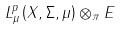Convert formula to latex. <formula><loc_0><loc_0><loc_500><loc_500>L _ { \mu } ^ { p } \left ( X , \Sigma , \mu \right ) \otimes _ { \pi } E</formula> 